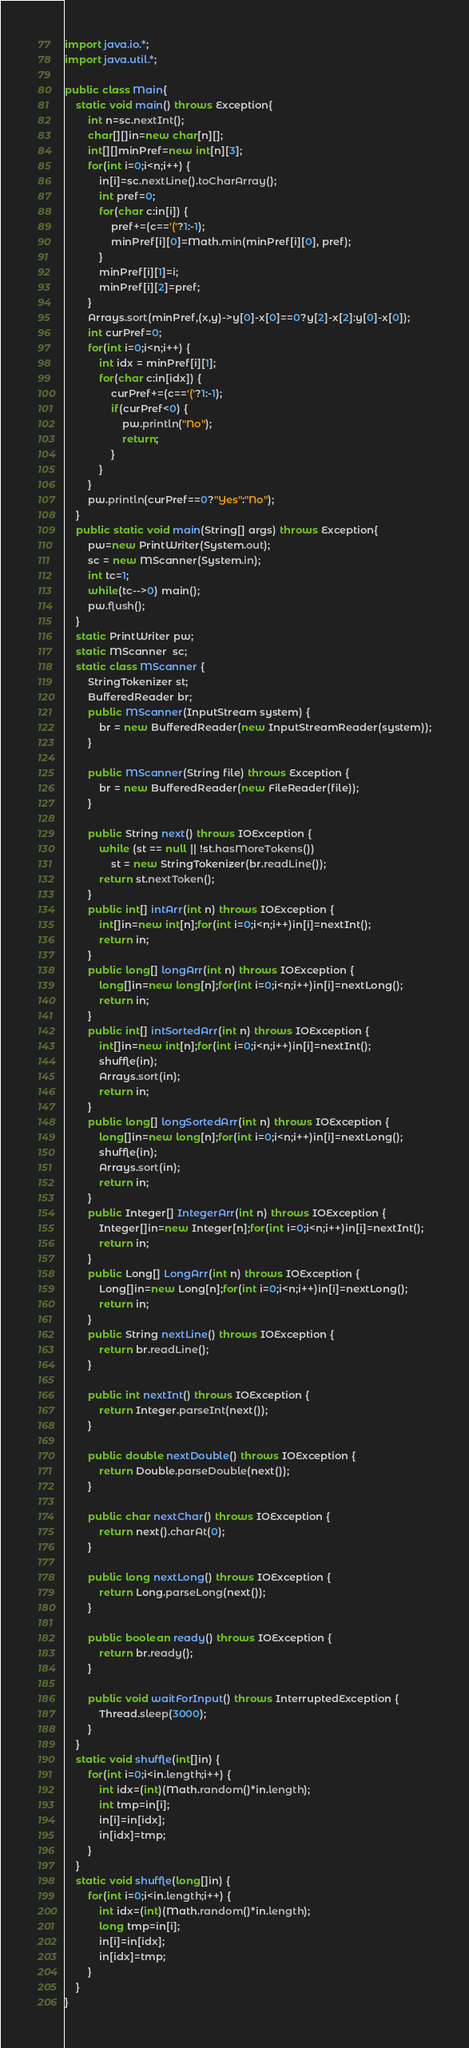Convert code to text. <code><loc_0><loc_0><loc_500><loc_500><_Java_>import java.io.*;
import java.util.*;

public class Main{
	static void main() throws Exception{
		int n=sc.nextInt();
		char[][]in=new char[n][];
		int[][]minPref=new int[n][3];
		for(int i=0;i<n;i++) {
			in[i]=sc.nextLine().toCharArray();
			int pref=0;
			for(char c:in[i]) {
				pref+=(c=='('?1:-1);
				minPref[i][0]=Math.min(minPref[i][0], pref);
			}
			minPref[i][1]=i;
			minPref[i][2]=pref;
		}
		Arrays.sort(minPref,(x,y)->y[0]-x[0]==0?y[2]-x[2]:y[0]-x[0]);
		int curPref=0;
		for(int i=0;i<n;i++) {
			int idx = minPref[i][1];
			for(char c:in[idx]) {
				curPref+=(c=='('?1:-1);
				if(curPref<0) {
					pw.println("No");
					return;
				}
			}
		}
		pw.println(curPref==0?"Yes":"No");
	}
	public static void main(String[] args) throws Exception{
		pw=new PrintWriter(System.out);
		sc = new MScanner(System.in);
		int tc=1;
		while(tc-->0) main();
		pw.flush();
	}
	static PrintWriter pw;
	static MScanner  sc;
	static class MScanner {
		StringTokenizer st;
		BufferedReader br;
		public MScanner(InputStream system) {
			br = new BufferedReader(new InputStreamReader(system));
		}
 
		public MScanner(String file) throws Exception {
			br = new BufferedReader(new FileReader(file));
		}
 
		public String next() throws IOException {
			while (st == null || !st.hasMoreTokens())
				st = new StringTokenizer(br.readLine());
			return st.nextToken();
		}
		public int[] intArr(int n) throws IOException {
	        int[]in=new int[n];for(int i=0;i<n;i++)in[i]=nextInt();
	        return in;
		}
		public long[] longArr(int n) throws IOException {
	        long[]in=new long[n];for(int i=0;i<n;i++)in[i]=nextLong();
	        return in;
		}
		public int[] intSortedArr(int n) throws IOException {
	        int[]in=new int[n];for(int i=0;i<n;i++)in[i]=nextInt();
	        shuffle(in);
	        Arrays.sort(in);
	        return in;
		}
		public long[] longSortedArr(int n) throws IOException {
	        long[]in=new long[n];for(int i=0;i<n;i++)in[i]=nextLong();
	        shuffle(in);
	        Arrays.sort(in);
	        return in;
		}
		public Integer[] IntegerArr(int n) throws IOException {
	        Integer[]in=new Integer[n];for(int i=0;i<n;i++)in[i]=nextInt();
	        return in;
		}
		public Long[] LongArr(int n) throws IOException {
	        Long[]in=new Long[n];for(int i=0;i<n;i++)in[i]=nextLong();
	        return in;
		}
		public String nextLine() throws IOException {
			return br.readLine();
		}
 
		public int nextInt() throws IOException {
			return Integer.parseInt(next());
		}
 
		public double nextDouble() throws IOException {
			return Double.parseDouble(next());
		}
 
		public char nextChar() throws IOException {
			return next().charAt(0);
		}
 
		public long nextLong() throws IOException {
			return Long.parseLong(next());
		}
 
		public boolean ready() throws IOException {
			return br.ready();
		}
 
		public void waitForInput() throws InterruptedException {
			Thread.sleep(3000);
		}
	}
	static void shuffle(int[]in) {
		for(int i=0;i<in.length;i++) {
			int idx=(int)(Math.random()*in.length);
			int tmp=in[i];
			in[i]=in[idx];
			in[idx]=tmp;
		}
	}
	static void shuffle(long[]in) {
		for(int i=0;i<in.length;i++) {
			int idx=(int)(Math.random()*in.length);
			long tmp=in[i];
			in[i]=in[idx];
			in[idx]=tmp;
		}
	}
}</code> 